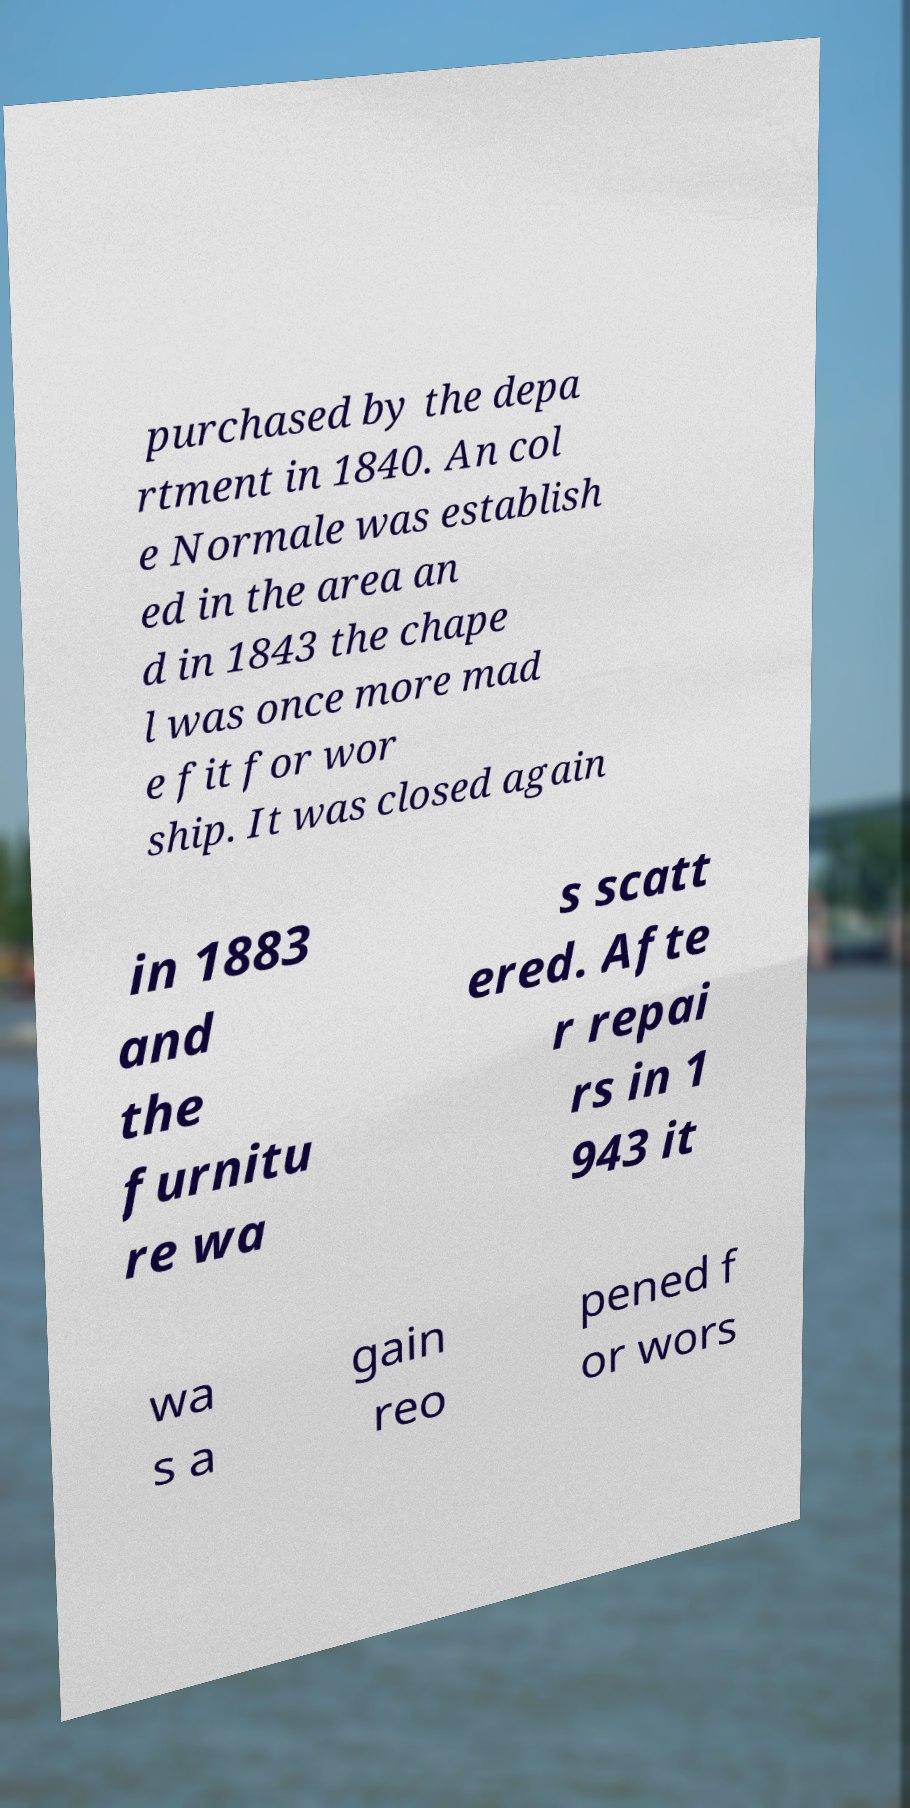What messages or text are displayed in this image? I need them in a readable, typed format. purchased by the depa rtment in 1840. An col e Normale was establish ed in the area an d in 1843 the chape l was once more mad e fit for wor ship. It was closed again in 1883 and the furnitu re wa s scatt ered. Afte r repai rs in 1 943 it wa s a gain reo pened f or wors 